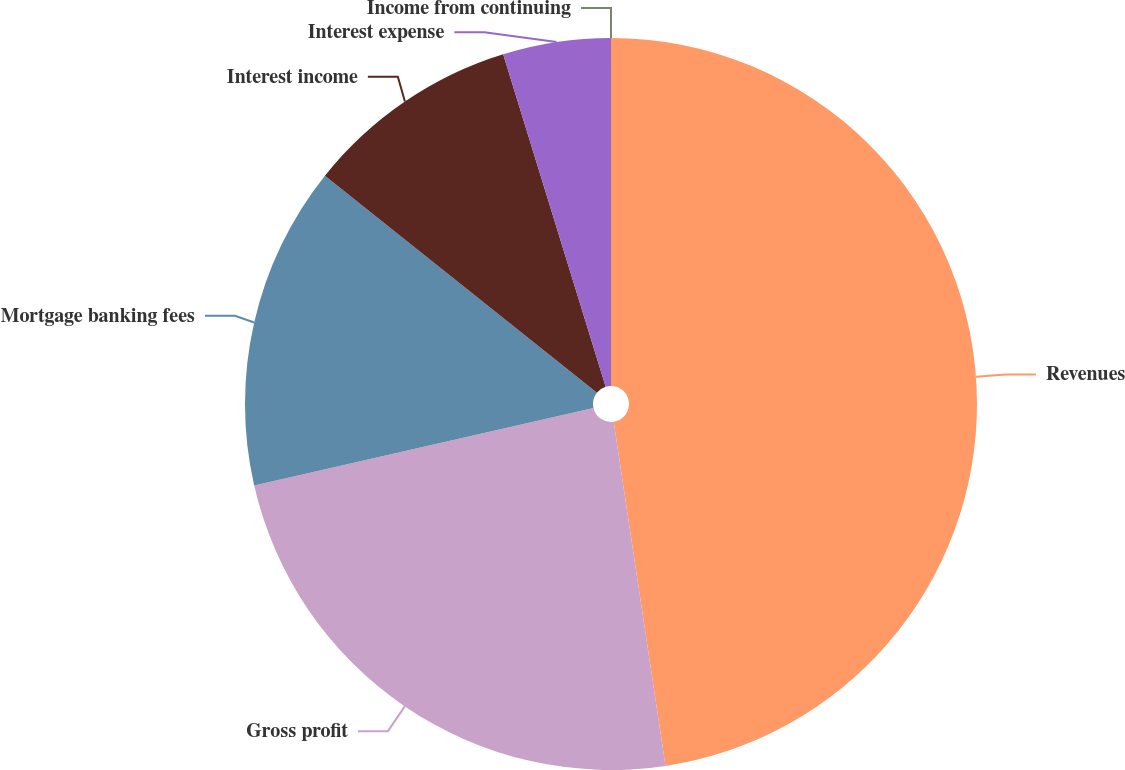Convert chart to OTSL. <chart><loc_0><loc_0><loc_500><loc_500><pie_chart><fcel>Revenues<fcel>Gross profit<fcel>Mortgage banking fees<fcel>Interest income<fcel>Interest expense<fcel>Income from continuing<nl><fcel>47.62%<fcel>23.81%<fcel>14.29%<fcel>9.52%<fcel>4.76%<fcel>0.0%<nl></chart> 